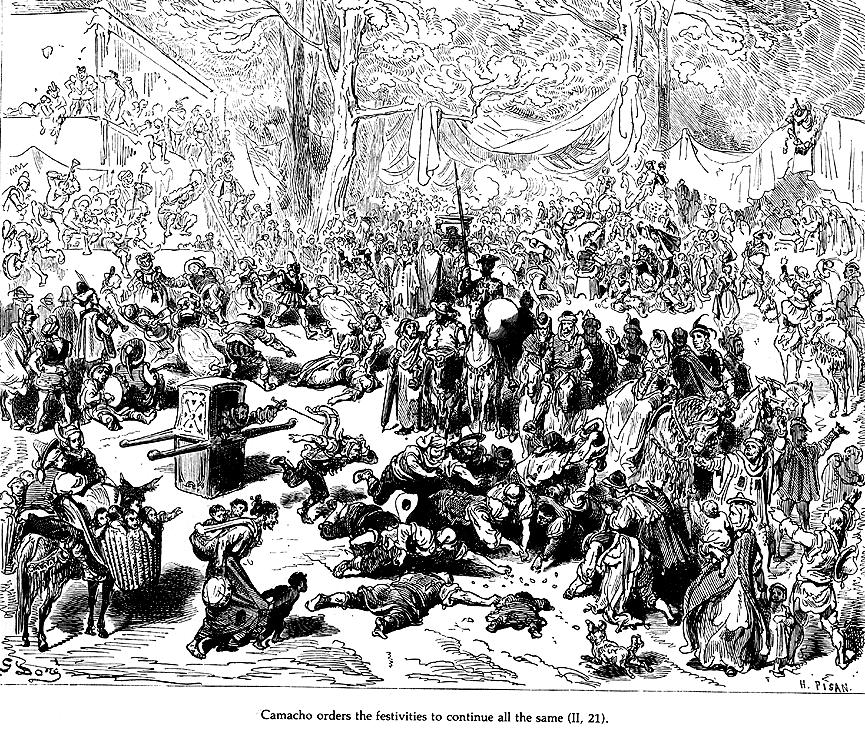What's happening in the scene? This detailed black and white illustration depicts a lively scene from Miguel de Cervantes' novel 'Don Quixote'. Set in a bustling forest, the image captures a festive gathering centered around Camacho, a wealthy farmer. The crowd, depicted with dramatic expressions and dynamic poses, focuses intently on Camacho's command to continue the celebrations despite underlying tensions. This woodcut-style illustration, filled with intricate details of costumes and gestures, not only visualizes the text but also conveys the lively and chaotic atmosphere of the event, highlighting themes of social hierarchy, festivity, and human character interaction in early modern Spain. 